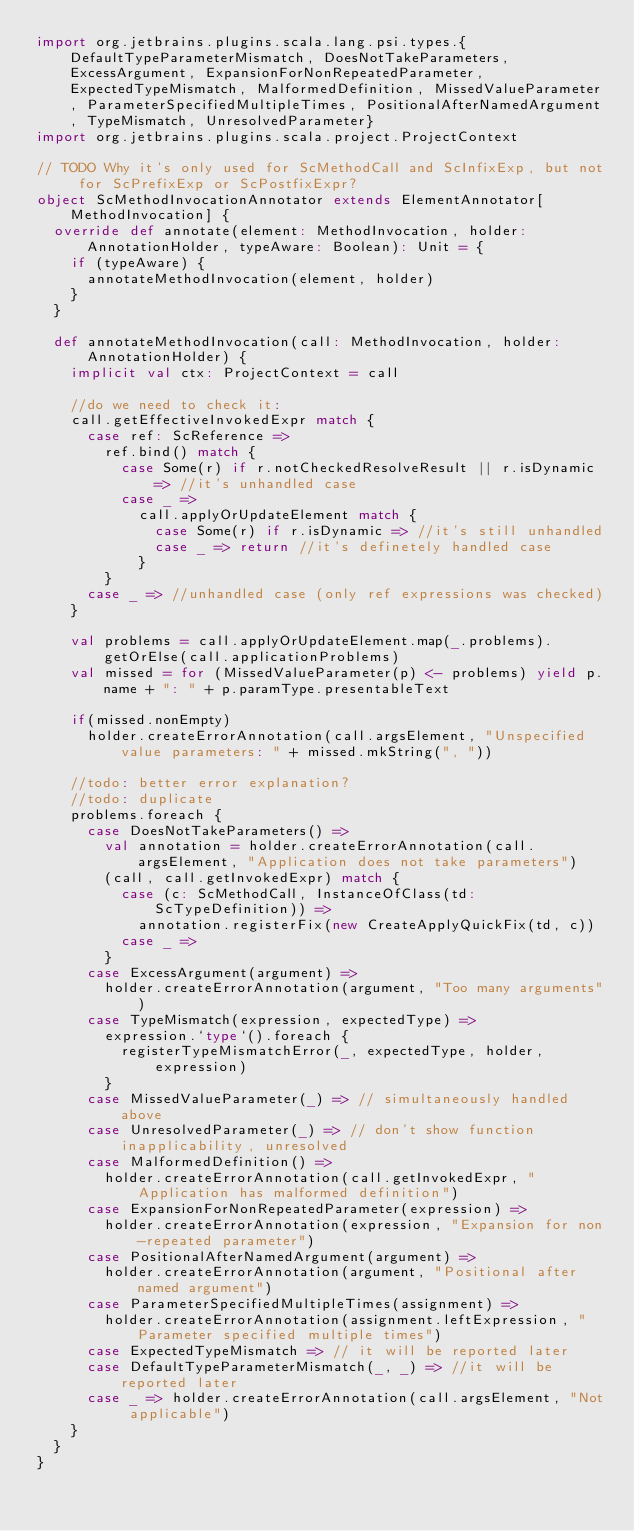Convert code to text. <code><loc_0><loc_0><loc_500><loc_500><_Scala_>import org.jetbrains.plugins.scala.lang.psi.types.{DefaultTypeParameterMismatch, DoesNotTakeParameters, ExcessArgument, ExpansionForNonRepeatedParameter, ExpectedTypeMismatch, MalformedDefinition, MissedValueParameter, ParameterSpecifiedMultipleTimes, PositionalAfterNamedArgument, TypeMismatch, UnresolvedParameter}
import org.jetbrains.plugins.scala.project.ProjectContext

// TODO Why it's only used for ScMethodCall and ScInfixExp, but not for ScPrefixExp or ScPostfixExpr?
object ScMethodInvocationAnnotator extends ElementAnnotator[MethodInvocation] {
  override def annotate(element: MethodInvocation, holder: AnnotationHolder, typeAware: Boolean): Unit = {
    if (typeAware) {
      annotateMethodInvocation(element, holder)
    }
  }

  def annotateMethodInvocation(call: MethodInvocation, holder: AnnotationHolder) {
    implicit val ctx: ProjectContext = call

    //do we need to check it:
    call.getEffectiveInvokedExpr match {
      case ref: ScReference =>
        ref.bind() match {
          case Some(r) if r.notCheckedResolveResult || r.isDynamic => //it's unhandled case
          case _ =>
            call.applyOrUpdateElement match {
              case Some(r) if r.isDynamic => //it's still unhandled
              case _ => return //it's definetely handled case
            }
        }
      case _ => //unhandled case (only ref expressions was checked)
    }

    val problems = call.applyOrUpdateElement.map(_.problems).getOrElse(call.applicationProblems)
    val missed = for (MissedValueParameter(p) <- problems) yield p.name + ": " + p.paramType.presentableText

    if(missed.nonEmpty)
      holder.createErrorAnnotation(call.argsElement, "Unspecified value parameters: " + missed.mkString(", "))

    //todo: better error explanation?
    //todo: duplicate
    problems.foreach {
      case DoesNotTakeParameters() =>
        val annotation = holder.createErrorAnnotation(call.argsElement, "Application does not take parameters")
        (call, call.getInvokedExpr) match {
          case (c: ScMethodCall, InstanceOfClass(td: ScTypeDefinition)) =>
            annotation.registerFix(new CreateApplyQuickFix(td, c))
          case _ =>
        }
      case ExcessArgument(argument) =>
        holder.createErrorAnnotation(argument, "Too many arguments")
      case TypeMismatch(expression, expectedType) =>
        expression.`type`().foreach {
          registerTypeMismatchError(_, expectedType, holder, expression)
        }
      case MissedValueParameter(_) => // simultaneously handled above
      case UnresolvedParameter(_) => // don't show function inapplicability, unresolved
      case MalformedDefinition() =>
        holder.createErrorAnnotation(call.getInvokedExpr, "Application has malformed definition")
      case ExpansionForNonRepeatedParameter(expression) =>
        holder.createErrorAnnotation(expression, "Expansion for non-repeated parameter")
      case PositionalAfterNamedArgument(argument) =>
        holder.createErrorAnnotation(argument, "Positional after named argument")
      case ParameterSpecifiedMultipleTimes(assignment) =>
        holder.createErrorAnnotation(assignment.leftExpression, "Parameter specified multiple times")
      case ExpectedTypeMismatch => // it will be reported later
      case DefaultTypeParameterMismatch(_, _) => //it will be reported later
      case _ => holder.createErrorAnnotation(call.argsElement, "Not applicable")
    }
  }
}
</code> 